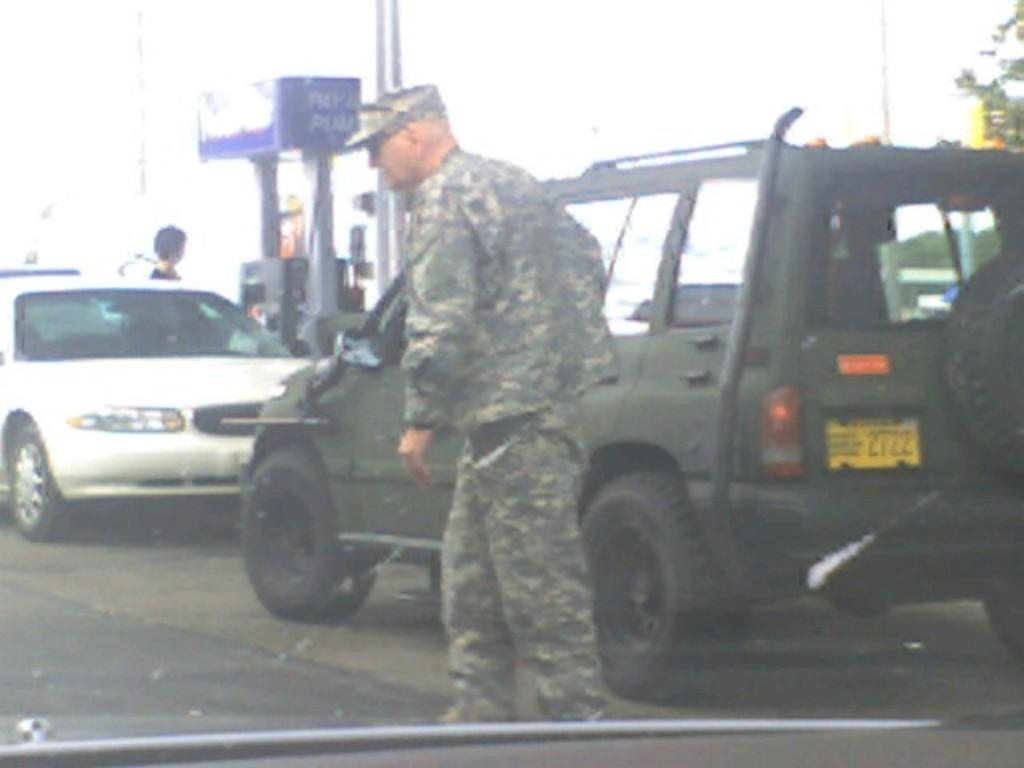Could you give a brief overview of what you see in this image? In the center of the image there is a person wearing a uniform. Behind him there is a car on the road. In the background of the image there is a fuel filling station. There is a white color car. 